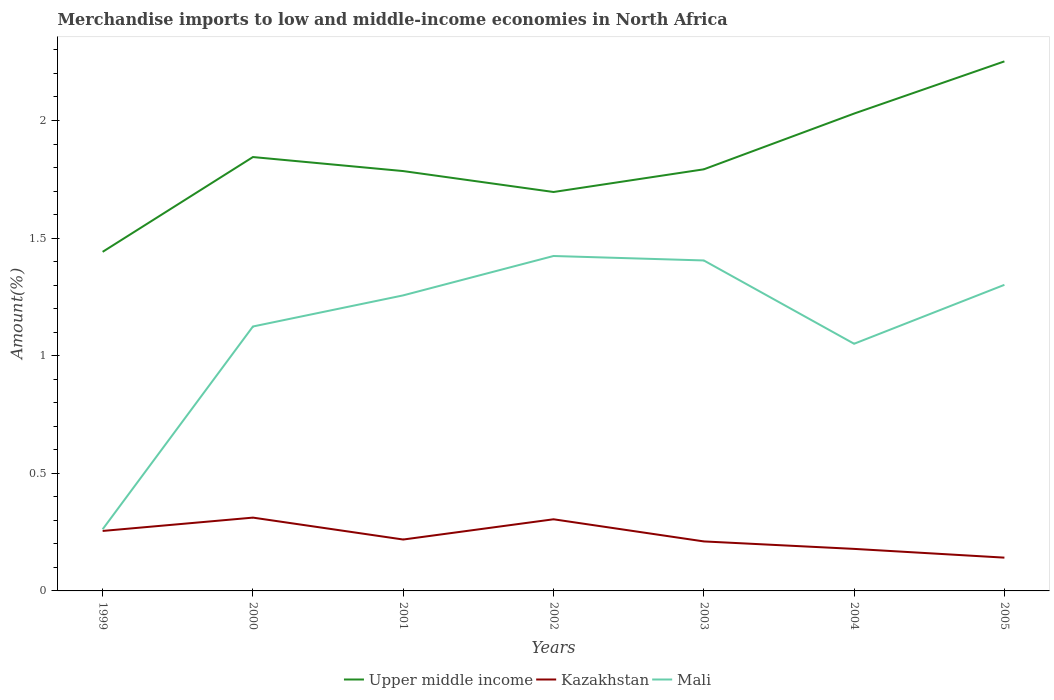How many different coloured lines are there?
Offer a very short reply. 3. Does the line corresponding to Mali intersect with the line corresponding to Kazakhstan?
Provide a succinct answer. No. Is the number of lines equal to the number of legend labels?
Provide a succinct answer. Yes. Across all years, what is the maximum percentage of amount earned from merchandise imports in Mali?
Your response must be concise. 0.26. In which year was the percentage of amount earned from merchandise imports in Kazakhstan maximum?
Keep it short and to the point. 2005. What is the total percentage of amount earned from merchandise imports in Kazakhstan in the graph?
Offer a terse response. 0.13. What is the difference between the highest and the second highest percentage of amount earned from merchandise imports in Kazakhstan?
Provide a short and direct response. 0.17. How many lines are there?
Provide a succinct answer. 3. How many years are there in the graph?
Make the answer very short. 7. Are the values on the major ticks of Y-axis written in scientific E-notation?
Ensure brevity in your answer.  No. How many legend labels are there?
Your response must be concise. 3. How are the legend labels stacked?
Your answer should be compact. Horizontal. What is the title of the graph?
Offer a very short reply. Merchandise imports to low and middle-income economies in North Africa. Does "Djibouti" appear as one of the legend labels in the graph?
Ensure brevity in your answer.  No. What is the label or title of the Y-axis?
Your response must be concise. Amount(%). What is the Amount(%) of Upper middle income in 1999?
Your answer should be very brief. 1.44. What is the Amount(%) in Kazakhstan in 1999?
Give a very brief answer. 0.25. What is the Amount(%) in Mali in 1999?
Your response must be concise. 0.26. What is the Amount(%) in Upper middle income in 2000?
Offer a terse response. 1.84. What is the Amount(%) of Kazakhstan in 2000?
Provide a short and direct response. 0.31. What is the Amount(%) of Mali in 2000?
Make the answer very short. 1.12. What is the Amount(%) in Upper middle income in 2001?
Your answer should be very brief. 1.78. What is the Amount(%) of Kazakhstan in 2001?
Keep it short and to the point. 0.22. What is the Amount(%) in Mali in 2001?
Your answer should be compact. 1.26. What is the Amount(%) of Upper middle income in 2002?
Provide a short and direct response. 1.7. What is the Amount(%) of Kazakhstan in 2002?
Your answer should be very brief. 0.3. What is the Amount(%) of Mali in 2002?
Keep it short and to the point. 1.42. What is the Amount(%) of Upper middle income in 2003?
Ensure brevity in your answer.  1.79. What is the Amount(%) in Kazakhstan in 2003?
Your response must be concise. 0.21. What is the Amount(%) in Mali in 2003?
Your answer should be very brief. 1.4. What is the Amount(%) in Upper middle income in 2004?
Make the answer very short. 2.03. What is the Amount(%) of Kazakhstan in 2004?
Give a very brief answer. 0.18. What is the Amount(%) in Mali in 2004?
Your answer should be very brief. 1.05. What is the Amount(%) of Upper middle income in 2005?
Offer a terse response. 2.25. What is the Amount(%) in Kazakhstan in 2005?
Provide a short and direct response. 0.14. What is the Amount(%) of Mali in 2005?
Make the answer very short. 1.3. Across all years, what is the maximum Amount(%) in Upper middle income?
Give a very brief answer. 2.25. Across all years, what is the maximum Amount(%) in Kazakhstan?
Keep it short and to the point. 0.31. Across all years, what is the maximum Amount(%) of Mali?
Your response must be concise. 1.42. Across all years, what is the minimum Amount(%) of Upper middle income?
Your answer should be compact. 1.44. Across all years, what is the minimum Amount(%) of Kazakhstan?
Provide a short and direct response. 0.14. Across all years, what is the minimum Amount(%) in Mali?
Keep it short and to the point. 0.26. What is the total Amount(%) of Upper middle income in the graph?
Offer a very short reply. 12.84. What is the total Amount(%) of Kazakhstan in the graph?
Provide a short and direct response. 1.62. What is the total Amount(%) in Mali in the graph?
Offer a very short reply. 7.82. What is the difference between the Amount(%) in Upper middle income in 1999 and that in 2000?
Offer a very short reply. -0.4. What is the difference between the Amount(%) in Kazakhstan in 1999 and that in 2000?
Ensure brevity in your answer.  -0.06. What is the difference between the Amount(%) of Mali in 1999 and that in 2000?
Provide a short and direct response. -0.86. What is the difference between the Amount(%) of Upper middle income in 1999 and that in 2001?
Offer a terse response. -0.34. What is the difference between the Amount(%) in Kazakhstan in 1999 and that in 2001?
Offer a very short reply. 0.04. What is the difference between the Amount(%) of Mali in 1999 and that in 2001?
Keep it short and to the point. -0.99. What is the difference between the Amount(%) of Upper middle income in 1999 and that in 2002?
Provide a succinct answer. -0.25. What is the difference between the Amount(%) of Kazakhstan in 1999 and that in 2002?
Your response must be concise. -0.05. What is the difference between the Amount(%) of Mali in 1999 and that in 2002?
Keep it short and to the point. -1.16. What is the difference between the Amount(%) in Upper middle income in 1999 and that in 2003?
Your answer should be very brief. -0.35. What is the difference between the Amount(%) of Kazakhstan in 1999 and that in 2003?
Your response must be concise. 0.04. What is the difference between the Amount(%) of Mali in 1999 and that in 2003?
Your answer should be very brief. -1.14. What is the difference between the Amount(%) in Upper middle income in 1999 and that in 2004?
Offer a very short reply. -0.59. What is the difference between the Amount(%) of Kazakhstan in 1999 and that in 2004?
Your response must be concise. 0.08. What is the difference between the Amount(%) of Mali in 1999 and that in 2004?
Ensure brevity in your answer.  -0.79. What is the difference between the Amount(%) in Upper middle income in 1999 and that in 2005?
Make the answer very short. -0.81. What is the difference between the Amount(%) of Kazakhstan in 1999 and that in 2005?
Make the answer very short. 0.11. What is the difference between the Amount(%) in Mali in 1999 and that in 2005?
Your response must be concise. -1.04. What is the difference between the Amount(%) in Upper middle income in 2000 and that in 2001?
Your answer should be very brief. 0.06. What is the difference between the Amount(%) in Kazakhstan in 2000 and that in 2001?
Provide a short and direct response. 0.09. What is the difference between the Amount(%) in Mali in 2000 and that in 2001?
Provide a succinct answer. -0.13. What is the difference between the Amount(%) of Upper middle income in 2000 and that in 2002?
Provide a short and direct response. 0.15. What is the difference between the Amount(%) of Kazakhstan in 2000 and that in 2002?
Give a very brief answer. 0.01. What is the difference between the Amount(%) in Mali in 2000 and that in 2002?
Offer a terse response. -0.3. What is the difference between the Amount(%) in Upper middle income in 2000 and that in 2003?
Make the answer very short. 0.05. What is the difference between the Amount(%) of Kazakhstan in 2000 and that in 2003?
Offer a very short reply. 0.1. What is the difference between the Amount(%) in Mali in 2000 and that in 2003?
Your answer should be very brief. -0.28. What is the difference between the Amount(%) of Upper middle income in 2000 and that in 2004?
Your answer should be very brief. -0.18. What is the difference between the Amount(%) in Kazakhstan in 2000 and that in 2004?
Keep it short and to the point. 0.13. What is the difference between the Amount(%) of Mali in 2000 and that in 2004?
Keep it short and to the point. 0.07. What is the difference between the Amount(%) of Upper middle income in 2000 and that in 2005?
Provide a short and direct response. -0.41. What is the difference between the Amount(%) in Kazakhstan in 2000 and that in 2005?
Ensure brevity in your answer.  0.17. What is the difference between the Amount(%) in Mali in 2000 and that in 2005?
Give a very brief answer. -0.18. What is the difference between the Amount(%) in Upper middle income in 2001 and that in 2002?
Keep it short and to the point. 0.09. What is the difference between the Amount(%) in Kazakhstan in 2001 and that in 2002?
Provide a short and direct response. -0.09. What is the difference between the Amount(%) in Mali in 2001 and that in 2002?
Offer a very short reply. -0.17. What is the difference between the Amount(%) of Upper middle income in 2001 and that in 2003?
Give a very brief answer. -0.01. What is the difference between the Amount(%) of Kazakhstan in 2001 and that in 2003?
Provide a short and direct response. 0.01. What is the difference between the Amount(%) in Mali in 2001 and that in 2003?
Your answer should be very brief. -0.15. What is the difference between the Amount(%) in Upper middle income in 2001 and that in 2004?
Give a very brief answer. -0.24. What is the difference between the Amount(%) in Kazakhstan in 2001 and that in 2004?
Offer a very short reply. 0.04. What is the difference between the Amount(%) of Mali in 2001 and that in 2004?
Make the answer very short. 0.21. What is the difference between the Amount(%) of Upper middle income in 2001 and that in 2005?
Keep it short and to the point. -0.47. What is the difference between the Amount(%) in Kazakhstan in 2001 and that in 2005?
Provide a succinct answer. 0.08. What is the difference between the Amount(%) in Mali in 2001 and that in 2005?
Provide a short and direct response. -0.04. What is the difference between the Amount(%) in Upper middle income in 2002 and that in 2003?
Offer a very short reply. -0.1. What is the difference between the Amount(%) in Kazakhstan in 2002 and that in 2003?
Offer a very short reply. 0.09. What is the difference between the Amount(%) of Mali in 2002 and that in 2003?
Keep it short and to the point. 0.02. What is the difference between the Amount(%) in Upper middle income in 2002 and that in 2004?
Ensure brevity in your answer.  -0.33. What is the difference between the Amount(%) of Kazakhstan in 2002 and that in 2004?
Provide a short and direct response. 0.13. What is the difference between the Amount(%) in Mali in 2002 and that in 2004?
Provide a succinct answer. 0.37. What is the difference between the Amount(%) in Upper middle income in 2002 and that in 2005?
Give a very brief answer. -0.56. What is the difference between the Amount(%) in Kazakhstan in 2002 and that in 2005?
Your answer should be very brief. 0.16. What is the difference between the Amount(%) of Mali in 2002 and that in 2005?
Give a very brief answer. 0.12. What is the difference between the Amount(%) in Upper middle income in 2003 and that in 2004?
Ensure brevity in your answer.  -0.24. What is the difference between the Amount(%) in Kazakhstan in 2003 and that in 2004?
Offer a terse response. 0.03. What is the difference between the Amount(%) of Mali in 2003 and that in 2004?
Offer a terse response. 0.35. What is the difference between the Amount(%) in Upper middle income in 2003 and that in 2005?
Provide a succinct answer. -0.46. What is the difference between the Amount(%) of Kazakhstan in 2003 and that in 2005?
Your answer should be compact. 0.07. What is the difference between the Amount(%) in Mali in 2003 and that in 2005?
Provide a succinct answer. 0.1. What is the difference between the Amount(%) in Upper middle income in 2004 and that in 2005?
Make the answer very short. -0.22. What is the difference between the Amount(%) in Kazakhstan in 2004 and that in 2005?
Ensure brevity in your answer.  0.04. What is the difference between the Amount(%) in Mali in 2004 and that in 2005?
Give a very brief answer. -0.25. What is the difference between the Amount(%) in Upper middle income in 1999 and the Amount(%) in Kazakhstan in 2000?
Keep it short and to the point. 1.13. What is the difference between the Amount(%) of Upper middle income in 1999 and the Amount(%) of Mali in 2000?
Offer a very short reply. 0.32. What is the difference between the Amount(%) of Kazakhstan in 1999 and the Amount(%) of Mali in 2000?
Your answer should be very brief. -0.87. What is the difference between the Amount(%) of Upper middle income in 1999 and the Amount(%) of Kazakhstan in 2001?
Keep it short and to the point. 1.22. What is the difference between the Amount(%) of Upper middle income in 1999 and the Amount(%) of Mali in 2001?
Provide a short and direct response. 0.18. What is the difference between the Amount(%) in Kazakhstan in 1999 and the Amount(%) in Mali in 2001?
Offer a very short reply. -1. What is the difference between the Amount(%) of Upper middle income in 1999 and the Amount(%) of Kazakhstan in 2002?
Provide a short and direct response. 1.14. What is the difference between the Amount(%) in Upper middle income in 1999 and the Amount(%) in Mali in 2002?
Provide a short and direct response. 0.02. What is the difference between the Amount(%) in Kazakhstan in 1999 and the Amount(%) in Mali in 2002?
Your answer should be compact. -1.17. What is the difference between the Amount(%) in Upper middle income in 1999 and the Amount(%) in Kazakhstan in 2003?
Offer a very short reply. 1.23. What is the difference between the Amount(%) in Upper middle income in 1999 and the Amount(%) in Mali in 2003?
Provide a short and direct response. 0.04. What is the difference between the Amount(%) of Kazakhstan in 1999 and the Amount(%) of Mali in 2003?
Ensure brevity in your answer.  -1.15. What is the difference between the Amount(%) in Upper middle income in 1999 and the Amount(%) in Kazakhstan in 2004?
Your response must be concise. 1.26. What is the difference between the Amount(%) of Upper middle income in 1999 and the Amount(%) of Mali in 2004?
Provide a short and direct response. 0.39. What is the difference between the Amount(%) of Kazakhstan in 1999 and the Amount(%) of Mali in 2004?
Keep it short and to the point. -0.8. What is the difference between the Amount(%) of Upper middle income in 1999 and the Amount(%) of Kazakhstan in 2005?
Provide a succinct answer. 1.3. What is the difference between the Amount(%) in Upper middle income in 1999 and the Amount(%) in Mali in 2005?
Provide a succinct answer. 0.14. What is the difference between the Amount(%) of Kazakhstan in 1999 and the Amount(%) of Mali in 2005?
Ensure brevity in your answer.  -1.05. What is the difference between the Amount(%) in Upper middle income in 2000 and the Amount(%) in Kazakhstan in 2001?
Ensure brevity in your answer.  1.63. What is the difference between the Amount(%) in Upper middle income in 2000 and the Amount(%) in Mali in 2001?
Your answer should be very brief. 0.59. What is the difference between the Amount(%) of Kazakhstan in 2000 and the Amount(%) of Mali in 2001?
Give a very brief answer. -0.94. What is the difference between the Amount(%) in Upper middle income in 2000 and the Amount(%) in Kazakhstan in 2002?
Offer a very short reply. 1.54. What is the difference between the Amount(%) of Upper middle income in 2000 and the Amount(%) of Mali in 2002?
Your response must be concise. 0.42. What is the difference between the Amount(%) of Kazakhstan in 2000 and the Amount(%) of Mali in 2002?
Provide a succinct answer. -1.11. What is the difference between the Amount(%) of Upper middle income in 2000 and the Amount(%) of Kazakhstan in 2003?
Provide a succinct answer. 1.63. What is the difference between the Amount(%) of Upper middle income in 2000 and the Amount(%) of Mali in 2003?
Provide a succinct answer. 0.44. What is the difference between the Amount(%) of Kazakhstan in 2000 and the Amount(%) of Mali in 2003?
Ensure brevity in your answer.  -1.09. What is the difference between the Amount(%) in Upper middle income in 2000 and the Amount(%) in Kazakhstan in 2004?
Ensure brevity in your answer.  1.67. What is the difference between the Amount(%) in Upper middle income in 2000 and the Amount(%) in Mali in 2004?
Your answer should be compact. 0.79. What is the difference between the Amount(%) of Kazakhstan in 2000 and the Amount(%) of Mali in 2004?
Give a very brief answer. -0.74. What is the difference between the Amount(%) of Upper middle income in 2000 and the Amount(%) of Kazakhstan in 2005?
Provide a short and direct response. 1.7. What is the difference between the Amount(%) of Upper middle income in 2000 and the Amount(%) of Mali in 2005?
Make the answer very short. 0.54. What is the difference between the Amount(%) in Kazakhstan in 2000 and the Amount(%) in Mali in 2005?
Make the answer very short. -0.99. What is the difference between the Amount(%) of Upper middle income in 2001 and the Amount(%) of Kazakhstan in 2002?
Ensure brevity in your answer.  1.48. What is the difference between the Amount(%) in Upper middle income in 2001 and the Amount(%) in Mali in 2002?
Offer a terse response. 0.36. What is the difference between the Amount(%) of Kazakhstan in 2001 and the Amount(%) of Mali in 2002?
Provide a short and direct response. -1.21. What is the difference between the Amount(%) in Upper middle income in 2001 and the Amount(%) in Kazakhstan in 2003?
Ensure brevity in your answer.  1.57. What is the difference between the Amount(%) in Upper middle income in 2001 and the Amount(%) in Mali in 2003?
Your answer should be compact. 0.38. What is the difference between the Amount(%) of Kazakhstan in 2001 and the Amount(%) of Mali in 2003?
Offer a very short reply. -1.19. What is the difference between the Amount(%) of Upper middle income in 2001 and the Amount(%) of Kazakhstan in 2004?
Make the answer very short. 1.61. What is the difference between the Amount(%) of Upper middle income in 2001 and the Amount(%) of Mali in 2004?
Keep it short and to the point. 0.73. What is the difference between the Amount(%) in Kazakhstan in 2001 and the Amount(%) in Mali in 2004?
Offer a terse response. -0.83. What is the difference between the Amount(%) in Upper middle income in 2001 and the Amount(%) in Kazakhstan in 2005?
Provide a succinct answer. 1.64. What is the difference between the Amount(%) in Upper middle income in 2001 and the Amount(%) in Mali in 2005?
Keep it short and to the point. 0.48. What is the difference between the Amount(%) of Kazakhstan in 2001 and the Amount(%) of Mali in 2005?
Offer a terse response. -1.08. What is the difference between the Amount(%) of Upper middle income in 2002 and the Amount(%) of Kazakhstan in 2003?
Keep it short and to the point. 1.49. What is the difference between the Amount(%) in Upper middle income in 2002 and the Amount(%) in Mali in 2003?
Offer a terse response. 0.29. What is the difference between the Amount(%) in Kazakhstan in 2002 and the Amount(%) in Mali in 2003?
Provide a short and direct response. -1.1. What is the difference between the Amount(%) of Upper middle income in 2002 and the Amount(%) of Kazakhstan in 2004?
Provide a short and direct response. 1.52. What is the difference between the Amount(%) in Upper middle income in 2002 and the Amount(%) in Mali in 2004?
Provide a succinct answer. 0.65. What is the difference between the Amount(%) in Kazakhstan in 2002 and the Amount(%) in Mali in 2004?
Offer a terse response. -0.75. What is the difference between the Amount(%) in Upper middle income in 2002 and the Amount(%) in Kazakhstan in 2005?
Your response must be concise. 1.55. What is the difference between the Amount(%) of Upper middle income in 2002 and the Amount(%) of Mali in 2005?
Your answer should be very brief. 0.39. What is the difference between the Amount(%) in Kazakhstan in 2002 and the Amount(%) in Mali in 2005?
Offer a terse response. -1. What is the difference between the Amount(%) in Upper middle income in 2003 and the Amount(%) in Kazakhstan in 2004?
Provide a succinct answer. 1.61. What is the difference between the Amount(%) in Upper middle income in 2003 and the Amount(%) in Mali in 2004?
Keep it short and to the point. 0.74. What is the difference between the Amount(%) in Kazakhstan in 2003 and the Amount(%) in Mali in 2004?
Give a very brief answer. -0.84. What is the difference between the Amount(%) in Upper middle income in 2003 and the Amount(%) in Kazakhstan in 2005?
Provide a short and direct response. 1.65. What is the difference between the Amount(%) of Upper middle income in 2003 and the Amount(%) of Mali in 2005?
Offer a very short reply. 0.49. What is the difference between the Amount(%) in Kazakhstan in 2003 and the Amount(%) in Mali in 2005?
Provide a succinct answer. -1.09. What is the difference between the Amount(%) of Upper middle income in 2004 and the Amount(%) of Kazakhstan in 2005?
Provide a succinct answer. 1.89. What is the difference between the Amount(%) in Upper middle income in 2004 and the Amount(%) in Mali in 2005?
Give a very brief answer. 0.73. What is the difference between the Amount(%) of Kazakhstan in 2004 and the Amount(%) of Mali in 2005?
Make the answer very short. -1.12. What is the average Amount(%) of Upper middle income per year?
Your answer should be compact. 1.83. What is the average Amount(%) of Kazakhstan per year?
Make the answer very short. 0.23. What is the average Amount(%) in Mali per year?
Make the answer very short. 1.12. In the year 1999, what is the difference between the Amount(%) of Upper middle income and Amount(%) of Kazakhstan?
Ensure brevity in your answer.  1.19. In the year 1999, what is the difference between the Amount(%) of Upper middle income and Amount(%) of Mali?
Your answer should be very brief. 1.18. In the year 1999, what is the difference between the Amount(%) in Kazakhstan and Amount(%) in Mali?
Keep it short and to the point. -0.01. In the year 2000, what is the difference between the Amount(%) of Upper middle income and Amount(%) of Kazakhstan?
Ensure brevity in your answer.  1.53. In the year 2000, what is the difference between the Amount(%) in Upper middle income and Amount(%) in Mali?
Your answer should be compact. 0.72. In the year 2000, what is the difference between the Amount(%) in Kazakhstan and Amount(%) in Mali?
Your answer should be compact. -0.81. In the year 2001, what is the difference between the Amount(%) of Upper middle income and Amount(%) of Kazakhstan?
Give a very brief answer. 1.57. In the year 2001, what is the difference between the Amount(%) in Upper middle income and Amount(%) in Mali?
Provide a short and direct response. 0.53. In the year 2001, what is the difference between the Amount(%) in Kazakhstan and Amount(%) in Mali?
Your answer should be very brief. -1.04. In the year 2002, what is the difference between the Amount(%) in Upper middle income and Amount(%) in Kazakhstan?
Your response must be concise. 1.39. In the year 2002, what is the difference between the Amount(%) of Upper middle income and Amount(%) of Mali?
Your response must be concise. 0.27. In the year 2002, what is the difference between the Amount(%) in Kazakhstan and Amount(%) in Mali?
Your answer should be compact. -1.12. In the year 2003, what is the difference between the Amount(%) in Upper middle income and Amount(%) in Kazakhstan?
Keep it short and to the point. 1.58. In the year 2003, what is the difference between the Amount(%) of Upper middle income and Amount(%) of Mali?
Your response must be concise. 0.39. In the year 2003, what is the difference between the Amount(%) in Kazakhstan and Amount(%) in Mali?
Make the answer very short. -1.19. In the year 2004, what is the difference between the Amount(%) of Upper middle income and Amount(%) of Kazakhstan?
Give a very brief answer. 1.85. In the year 2004, what is the difference between the Amount(%) in Upper middle income and Amount(%) in Mali?
Your answer should be very brief. 0.98. In the year 2004, what is the difference between the Amount(%) of Kazakhstan and Amount(%) of Mali?
Offer a terse response. -0.87. In the year 2005, what is the difference between the Amount(%) of Upper middle income and Amount(%) of Kazakhstan?
Provide a succinct answer. 2.11. In the year 2005, what is the difference between the Amount(%) of Kazakhstan and Amount(%) of Mali?
Provide a short and direct response. -1.16. What is the ratio of the Amount(%) of Upper middle income in 1999 to that in 2000?
Give a very brief answer. 0.78. What is the ratio of the Amount(%) in Kazakhstan in 1999 to that in 2000?
Provide a succinct answer. 0.82. What is the ratio of the Amount(%) in Mali in 1999 to that in 2000?
Make the answer very short. 0.23. What is the ratio of the Amount(%) in Upper middle income in 1999 to that in 2001?
Your answer should be compact. 0.81. What is the ratio of the Amount(%) in Kazakhstan in 1999 to that in 2001?
Offer a terse response. 1.17. What is the ratio of the Amount(%) of Mali in 1999 to that in 2001?
Provide a succinct answer. 0.21. What is the ratio of the Amount(%) in Kazakhstan in 1999 to that in 2002?
Offer a very short reply. 0.84. What is the ratio of the Amount(%) in Mali in 1999 to that in 2002?
Keep it short and to the point. 0.18. What is the ratio of the Amount(%) of Upper middle income in 1999 to that in 2003?
Make the answer very short. 0.8. What is the ratio of the Amount(%) in Kazakhstan in 1999 to that in 2003?
Keep it short and to the point. 1.21. What is the ratio of the Amount(%) in Mali in 1999 to that in 2003?
Ensure brevity in your answer.  0.19. What is the ratio of the Amount(%) of Upper middle income in 1999 to that in 2004?
Keep it short and to the point. 0.71. What is the ratio of the Amount(%) of Kazakhstan in 1999 to that in 2004?
Your answer should be compact. 1.43. What is the ratio of the Amount(%) in Mali in 1999 to that in 2004?
Provide a succinct answer. 0.25. What is the ratio of the Amount(%) of Upper middle income in 1999 to that in 2005?
Provide a short and direct response. 0.64. What is the ratio of the Amount(%) of Kazakhstan in 1999 to that in 2005?
Offer a terse response. 1.8. What is the ratio of the Amount(%) in Mali in 1999 to that in 2005?
Offer a very short reply. 0.2. What is the ratio of the Amount(%) of Upper middle income in 2000 to that in 2001?
Ensure brevity in your answer.  1.03. What is the ratio of the Amount(%) of Kazakhstan in 2000 to that in 2001?
Make the answer very short. 1.43. What is the ratio of the Amount(%) in Mali in 2000 to that in 2001?
Your answer should be compact. 0.89. What is the ratio of the Amount(%) of Upper middle income in 2000 to that in 2002?
Offer a terse response. 1.09. What is the ratio of the Amount(%) in Kazakhstan in 2000 to that in 2002?
Your response must be concise. 1.02. What is the ratio of the Amount(%) of Mali in 2000 to that in 2002?
Make the answer very short. 0.79. What is the ratio of the Amount(%) in Upper middle income in 2000 to that in 2003?
Ensure brevity in your answer.  1.03. What is the ratio of the Amount(%) of Kazakhstan in 2000 to that in 2003?
Offer a terse response. 1.48. What is the ratio of the Amount(%) of Mali in 2000 to that in 2003?
Offer a very short reply. 0.8. What is the ratio of the Amount(%) of Upper middle income in 2000 to that in 2004?
Give a very brief answer. 0.91. What is the ratio of the Amount(%) in Kazakhstan in 2000 to that in 2004?
Offer a terse response. 1.74. What is the ratio of the Amount(%) of Mali in 2000 to that in 2004?
Provide a short and direct response. 1.07. What is the ratio of the Amount(%) in Upper middle income in 2000 to that in 2005?
Ensure brevity in your answer.  0.82. What is the ratio of the Amount(%) of Kazakhstan in 2000 to that in 2005?
Give a very brief answer. 2.2. What is the ratio of the Amount(%) in Mali in 2000 to that in 2005?
Your answer should be compact. 0.86. What is the ratio of the Amount(%) of Upper middle income in 2001 to that in 2002?
Provide a succinct answer. 1.05. What is the ratio of the Amount(%) in Kazakhstan in 2001 to that in 2002?
Your answer should be very brief. 0.72. What is the ratio of the Amount(%) in Mali in 2001 to that in 2002?
Your answer should be compact. 0.88. What is the ratio of the Amount(%) of Kazakhstan in 2001 to that in 2003?
Keep it short and to the point. 1.04. What is the ratio of the Amount(%) of Mali in 2001 to that in 2003?
Offer a terse response. 0.89. What is the ratio of the Amount(%) of Upper middle income in 2001 to that in 2004?
Your response must be concise. 0.88. What is the ratio of the Amount(%) in Kazakhstan in 2001 to that in 2004?
Keep it short and to the point. 1.22. What is the ratio of the Amount(%) in Mali in 2001 to that in 2004?
Ensure brevity in your answer.  1.2. What is the ratio of the Amount(%) in Upper middle income in 2001 to that in 2005?
Give a very brief answer. 0.79. What is the ratio of the Amount(%) of Kazakhstan in 2001 to that in 2005?
Provide a short and direct response. 1.54. What is the ratio of the Amount(%) of Mali in 2001 to that in 2005?
Keep it short and to the point. 0.97. What is the ratio of the Amount(%) in Upper middle income in 2002 to that in 2003?
Make the answer very short. 0.95. What is the ratio of the Amount(%) in Kazakhstan in 2002 to that in 2003?
Provide a succinct answer. 1.45. What is the ratio of the Amount(%) in Mali in 2002 to that in 2003?
Give a very brief answer. 1.01. What is the ratio of the Amount(%) in Upper middle income in 2002 to that in 2004?
Provide a succinct answer. 0.84. What is the ratio of the Amount(%) of Kazakhstan in 2002 to that in 2004?
Give a very brief answer. 1.7. What is the ratio of the Amount(%) of Mali in 2002 to that in 2004?
Offer a very short reply. 1.36. What is the ratio of the Amount(%) of Upper middle income in 2002 to that in 2005?
Provide a short and direct response. 0.75. What is the ratio of the Amount(%) in Kazakhstan in 2002 to that in 2005?
Offer a terse response. 2.15. What is the ratio of the Amount(%) of Mali in 2002 to that in 2005?
Provide a short and direct response. 1.09. What is the ratio of the Amount(%) in Upper middle income in 2003 to that in 2004?
Your answer should be very brief. 0.88. What is the ratio of the Amount(%) in Kazakhstan in 2003 to that in 2004?
Offer a terse response. 1.18. What is the ratio of the Amount(%) of Mali in 2003 to that in 2004?
Your answer should be very brief. 1.34. What is the ratio of the Amount(%) of Upper middle income in 2003 to that in 2005?
Ensure brevity in your answer.  0.8. What is the ratio of the Amount(%) of Kazakhstan in 2003 to that in 2005?
Make the answer very short. 1.49. What is the ratio of the Amount(%) of Mali in 2003 to that in 2005?
Your response must be concise. 1.08. What is the ratio of the Amount(%) in Upper middle income in 2004 to that in 2005?
Ensure brevity in your answer.  0.9. What is the ratio of the Amount(%) in Kazakhstan in 2004 to that in 2005?
Your answer should be compact. 1.26. What is the ratio of the Amount(%) in Mali in 2004 to that in 2005?
Your response must be concise. 0.81. What is the difference between the highest and the second highest Amount(%) of Upper middle income?
Make the answer very short. 0.22. What is the difference between the highest and the second highest Amount(%) in Kazakhstan?
Your response must be concise. 0.01. What is the difference between the highest and the second highest Amount(%) of Mali?
Ensure brevity in your answer.  0.02. What is the difference between the highest and the lowest Amount(%) in Upper middle income?
Make the answer very short. 0.81. What is the difference between the highest and the lowest Amount(%) in Kazakhstan?
Keep it short and to the point. 0.17. What is the difference between the highest and the lowest Amount(%) of Mali?
Your response must be concise. 1.16. 